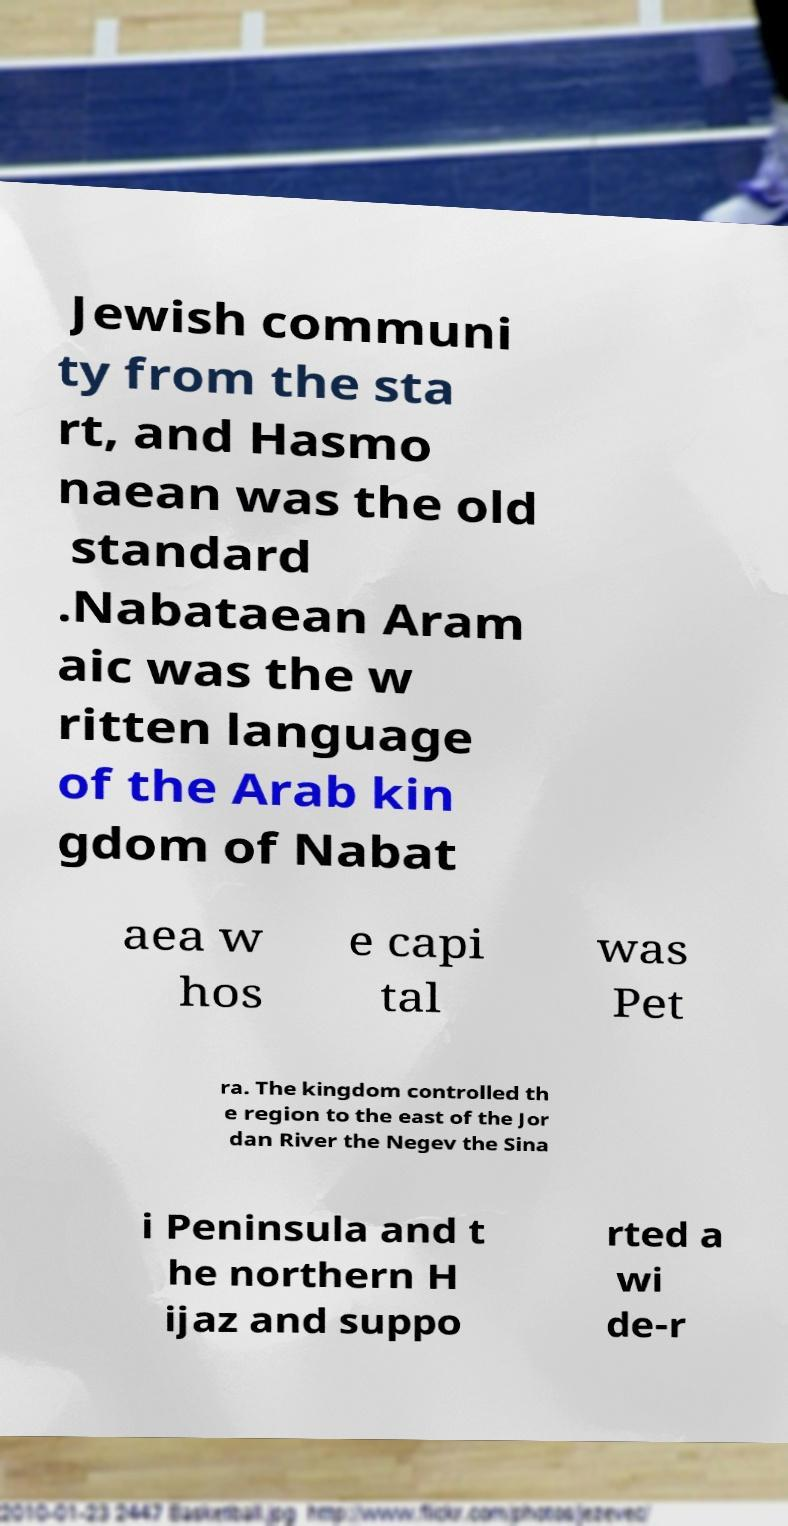Can you read and provide the text displayed in the image?This photo seems to have some interesting text. Can you extract and type it out for me? Jewish communi ty from the sta rt, and Hasmo naean was the old standard .Nabataean Aram aic was the w ritten language of the Arab kin gdom of Nabat aea w hos e capi tal was Pet ra. The kingdom controlled th e region to the east of the Jor dan River the Negev the Sina i Peninsula and t he northern H ijaz and suppo rted a wi de-r 